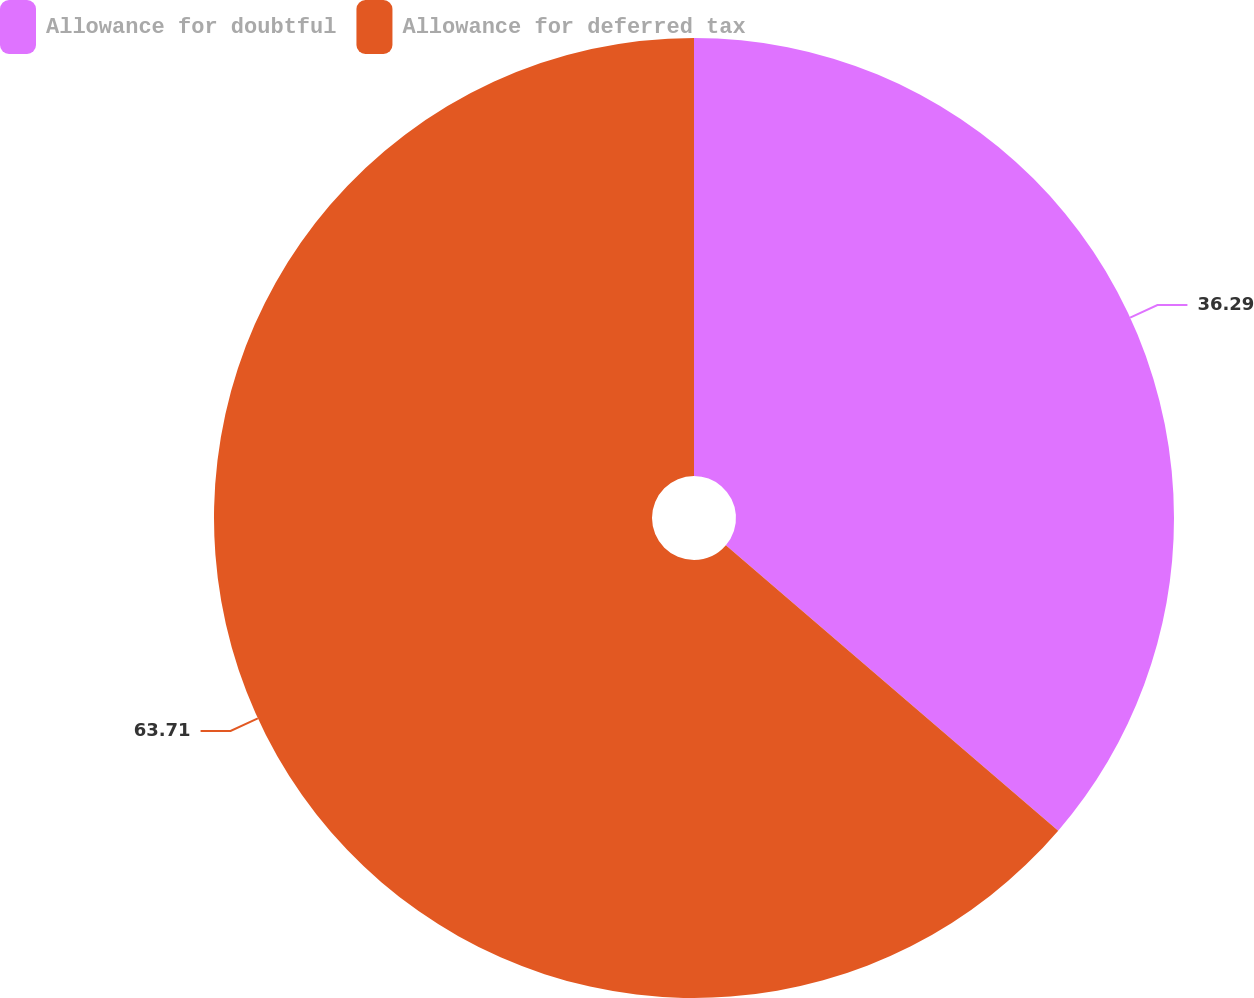Convert chart. <chart><loc_0><loc_0><loc_500><loc_500><pie_chart><fcel>Allowance for doubtful<fcel>Allowance for deferred tax<nl><fcel>36.29%<fcel>63.71%<nl></chart> 